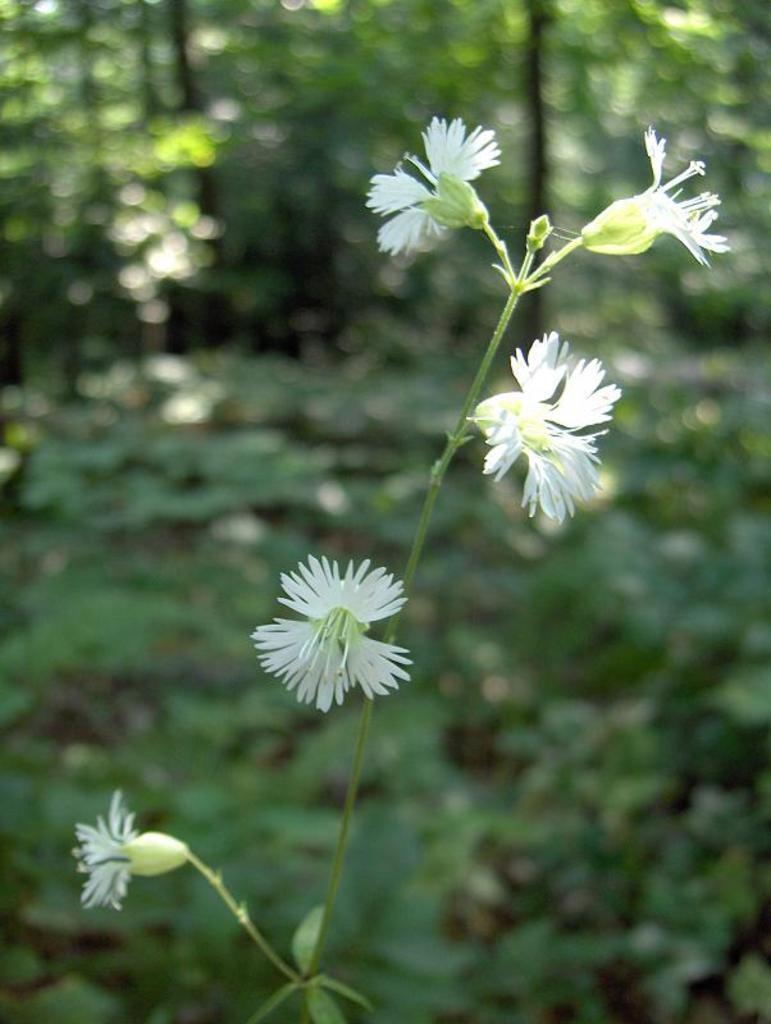Can you describe this image briefly? In this image I can see the white color flowers to the plant. In the back there are many trees and it is blurry. 